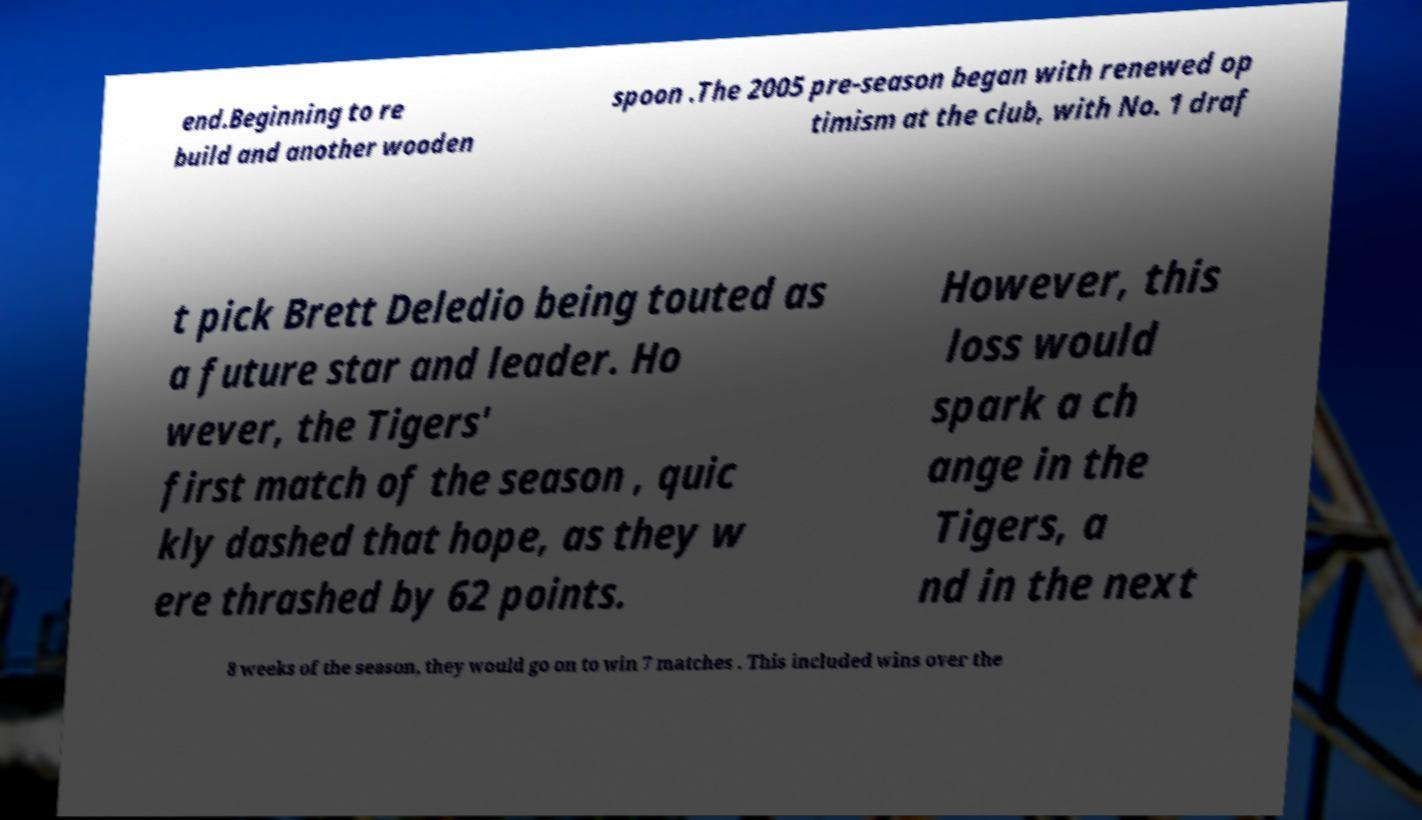I need the written content from this picture converted into text. Can you do that? end.Beginning to re build and another wooden spoon .The 2005 pre-season began with renewed op timism at the club, with No. 1 draf t pick Brett Deledio being touted as a future star and leader. Ho wever, the Tigers' first match of the season , quic kly dashed that hope, as they w ere thrashed by 62 points. However, this loss would spark a ch ange in the Tigers, a nd in the next 8 weeks of the season, they would go on to win 7 matches . This included wins over the 